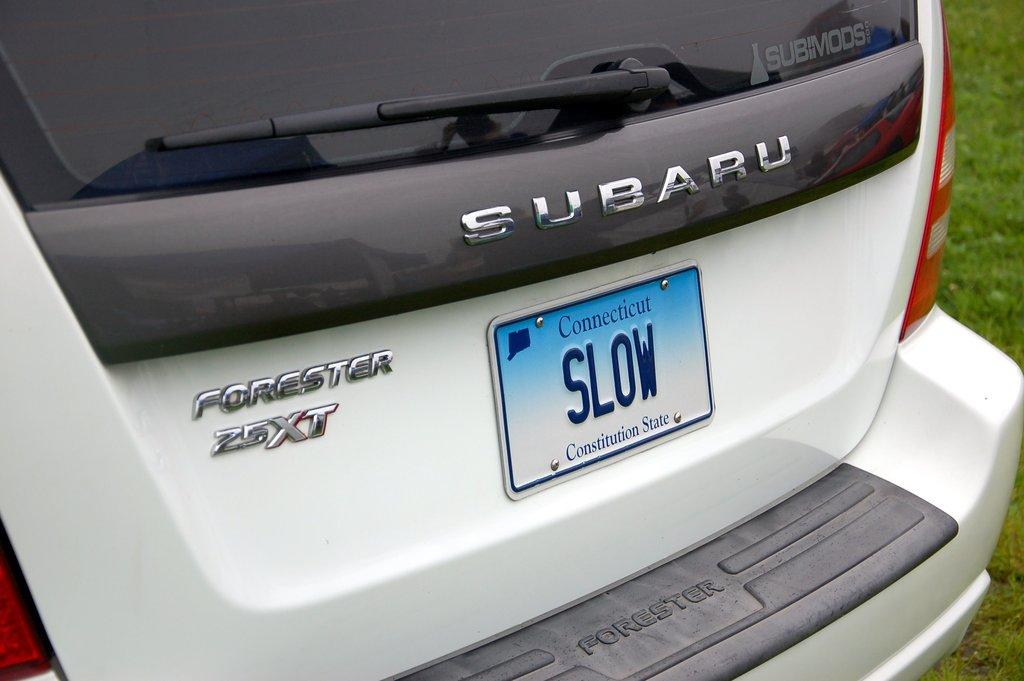What color is the vehicle in the image? The vehicle in the image is white. Are there any words or letters on the vehicle? Yes, there is some text on the vehicle. What type of natural environment can be seen in the image? Grass is visible in the image. How many hours of sleep can be seen in the image? There is no indication of sleep or any sleeping object in the image. 